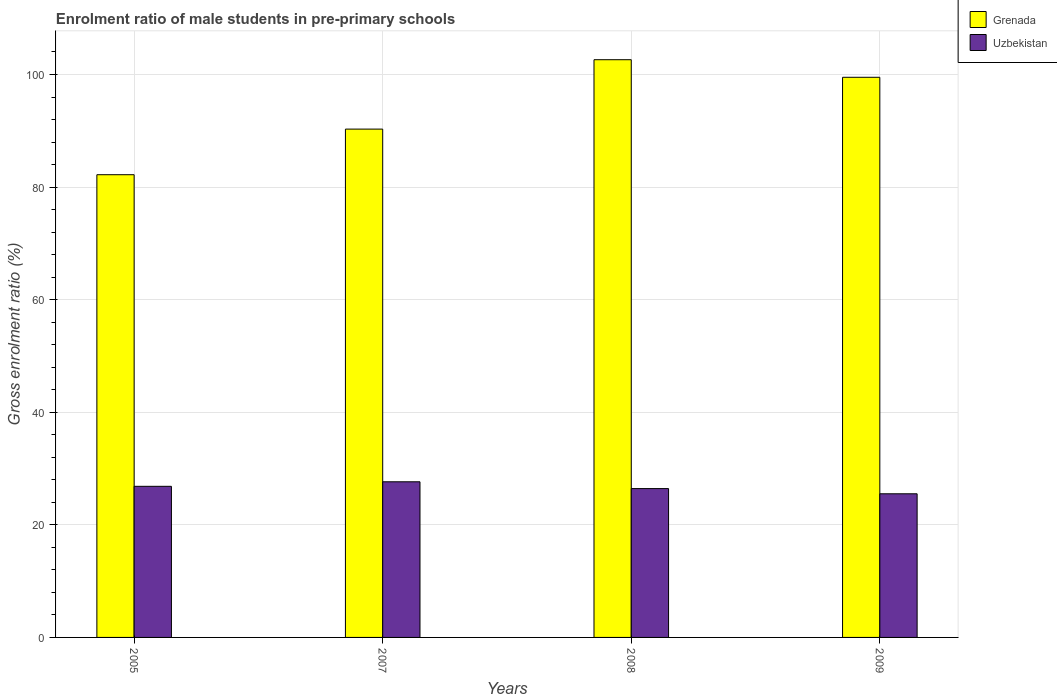How many different coloured bars are there?
Your answer should be very brief. 2. Are the number of bars on each tick of the X-axis equal?
Your response must be concise. Yes. In how many cases, is the number of bars for a given year not equal to the number of legend labels?
Offer a terse response. 0. What is the enrolment ratio of male students in pre-primary schools in Uzbekistan in 2009?
Keep it short and to the point. 25.52. Across all years, what is the maximum enrolment ratio of male students in pre-primary schools in Grenada?
Ensure brevity in your answer.  102.63. Across all years, what is the minimum enrolment ratio of male students in pre-primary schools in Grenada?
Give a very brief answer. 82.2. What is the total enrolment ratio of male students in pre-primary schools in Uzbekistan in the graph?
Your response must be concise. 106.45. What is the difference between the enrolment ratio of male students in pre-primary schools in Grenada in 2005 and that in 2007?
Your answer should be very brief. -8.1. What is the difference between the enrolment ratio of male students in pre-primary schools in Uzbekistan in 2008 and the enrolment ratio of male students in pre-primary schools in Grenada in 2009?
Offer a very short reply. -73.07. What is the average enrolment ratio of male students in pre-primary schools in Grenada per year?
Offer a terse response. 93.66. In the year 2009, what is the difference between the enrolment ratio of male students in pre-primary schools in Grenada and enrolment ratio of male students in pre-primary schools in Uzbekistan?
Provide a succinct answer. 73.99. What is the ratio of the enrolment ratio of male students in pre-primary schools in Grenada in 2005 to that in 2009?
Provide a short and direct response. 0.83. Is the enrolment ratio of male students in pre-primary schools in Grenada in 2005 less than that in 2009?
Ensure brevity in your answer.  Yes. What is the difference between the highest and the second highest enrolment ratio of male students in pre-primary schools in Grenada?
Provide a short and direct response. 3.12. What is the difference between the highest and the lowest enrolment ratio of male students in pre-primary schools in Uzbekistan?
Offer a terse response. 2.13. What does the 1st bar from the left in 2007 represents?
Your response must be concise. Grenada. What does the 2nd bar from the right in 2008 represents?
Provide a short and direct response. Grenada. How many years are there in the graph?
Make the answer very short. 4. What is the difference between two consecutive major ticks on the Y-axis?
Give a very brief answer. 20. Are the values on the major ticks of Y-axis written in scientific E-notation?
Your response must be concise. No. Does the graph contain any zero values?
Your answer should be compact. No. Where does the legend appear in the graph?
Provide a short and direct response. Top right. How many legend labels are there?
Your answer should be compact. 2. What is the title of the graph?
Provide a succinct answer. Enrolment ratio of male students in pre-primary schools. What is the label or title of the Y-axis?
Your answer should be very brief. Gross enrolment ratio (%). What is the Gross enrolment ratio (%) of Grenada in 2005?
Offer a very short reply. 82.2. What is the Gross enrolment ratio (%) in Uzbekistan in 2005?
Your answer should be very brief. 26.84. What is the Gross enrolment ratio (%) in Grenada in 2007?
Your answer should be compact. 90.3. What is the Gross enrolment ratio (%) in Uzbekistan in 2007?
Give a very brief answer. 27.65. What is the Gross enrolment ratio (%) of Grenada in 2008?
Ensure brevity in your answer.  102.63. What is the Gross enrolment ratio (%) of Uzbekistan in 2008?
Offer a very short reply. 26.44. What is the Gross enrolment ratio (%) in Grenada in 2009?
Provide a short and direct response. 99.51. What is the Gross enrolment ratio (%) in Uzbekistan in 2009?
Provide a succinct answer. 25.52. Across all years, what is the maximum Gross enrolment ratio (%) of Grenada?
Offer a very short reply. 102.63. Across all years, what is the maximum Gross enrolment ratio (%) of Uzbekistan?
Keep it short and to the point. 27.65. Across all years, what is the minimum Gross enrolment ratio (%) in Grenada?
Your response must be concise. 82.2. Across all years, what is the minimum Gross enrolment ratio (%) in Uzbekistan?
Offer a very short reply. 25.52. What is the total Gross enrolment ratio (%) of Grenada in the graph?
Your answer should be very brief. 374.64. What is the total Gross enrolment ratio (%) in Uzbekistan in the graph?
Provide a short and direct response. 106.45. What is the difference between the Gross enrolment ratio (%) of Grenada in 2005 and that in 2007?
Give a very brief answer. -8.1. What is the difference between the Gross enrolment ratio (%) in Uzbekistan in 2005 and that in 2007?
Provide a succinct answer. -0.8. What is the difference between the Gross enrolment ratio (%) in Grenada in 2005 and that in 2008?
Make the answer very short. -20.43. What is the difference between the Gross enrolment ratio (%) in Uzbekistan in 2005 and that in 2008?
Offer a very short reply. 0.4. What is the difference between the Gross enrolment ratio (%) of Grenada in 2005 and that in 2009?
Keep it short and to the point. -17.31. What is the difference between the Gross enrolment ratio (%) of Uzbekistan in 2005 and that in 2009?
Give a very brief answer. 1.33. What is the difference between the Gross enrolment ratio (%) in Grenada in 2007 and that in 2008?
Keep it short and to the point. -12.33. What is the difference between the Gross enrolment ratio (%) of Uzbekistan in 2007 and that in 2008?
Offer a very short reply. 1.21. What is the difference between the Gross enrolment ratio (%) in Grenada in 2007 and that in 2009?
Ensure brevity in your answer.  -9.2. What is the difference between the Gross enrolment ratio (%) of Uzbekistan in 2007 and that in 2009?
Offer a very short reply. 2.13. What is the difference between the Gross enrolment ratio (%) in Grenada in 2008 and that in 2009?
Your answer should be compact. 3.12. What is the difference between the Gross enrolment ratio (%) of Uzbekistan in 2008 and that in 2009?
Keep it short and to the point. 0.92. What is the difference between the Gross enrolment ratio (%) in Grenada in 2005 and the Gross enrolment ratio (%) in Uzbekistan in 2007?
Provide a succinct answer. 54.55. What is the difference between the Gross enrolment ratio (%) of Grenada in 2005 and the Gross enrolment ratio (%) of Uzbekistan in 2008?
Offer a very short reply. 55.76. What is the difference between the Gross enrolment ratio (%) in Grenada in 2005 and the Gross enrolment ratio (%) in Uzbekistan in 2009?
Provide a short and direct response. 56.68. What is the difference between the Gross enrolment ratio (%) in Grenada in 2007 and the Gross enrolment ratio (%) in Uzbekistan in 2008?
Your answer should be compact. 63.86. What is the difference between the Gross enrolment ratio (%) in Grenada in 2007 and the Gross enrolment ratio (%) in Uzbekistan in 2009?
Your answer should be compact. 64.79. What is the difference between the Gross enrolment ratio (%) of Grenada in 2008 and the Gross enrolment ratio (%) of Uzbekistan in 2009?
Make the answer very short. 77.11. What is the average Gross enrolment ratio (%) in Grenada per year?
Provide a succinct answer. 93.66. What is the average Gross enrolment ratio (%) in Uzbekistan per year?
Your answer should be compact. 26.61. In the year 2005, what is the difference between the Gross enrolment ratio (%) of Grenada and Gross enrolment ratio (%) of Uzbekistan?
Ensure brevity in your answer.  55.35. In the year 2007, what is the difference between the Gross enrolment ratio (%) in Grenada and Gross enrolment ratio (%) in Uzbekistan?
Provide a succinct answer. 62.65. In the year 2008, what is the difference between the Gross enrolment ratio (%) of Grenada and Gross enrolment ratio (%) of Uzbekistan?
Provide a succinct answer. 76.19. In the year 2009, what is the difference between the Gross enrolment ratio (%) of Grenada and Gross enrolment ratio (%) of Uzbekistan?
Offer a terse response. 73.99. What is the ratio of the Gross enrolment ratio (%) of Grenada in 2005 to that in 2007?
Give a very brief answer. 0.91. What is the ratio of the Gross enrolment ratio (%) of Uzbekistan in 2005 to that in 2007?
Your answer should be compact. 0.97. What is the ratio of the Gross enrolment ratio (%) in Grenada in 2005 to that in 2008?
Provide a short and direct response. 0.8. What is the ratio of the Gross enrolment ratio (%) in Uzbekistan in 2005 to that in 2008?
Provide a short and direct response. 1.02. What is the ratio of the Gross enrolment ratio (%) in Grenada in 2005 to that in 2009?
Make the answer very short. 0.83. What is the ratio of the Gross enrolment ratio (%) of Uzbekistan in 2005 to that in 2009?
Offer a terse response. 1.05. What is the ratio of the Gross enrolment ratio (%) in Grenada in 2007 to that in 2008?
Your response must be concise. 0.88. What is the ratio of the Gross enrolment ratio (%) of Uzbekistan in 2007 to that in 2008?
Ensure brevity in your answer.  1.05. What is the ratio of the Gross enrolment ratio (%) in Grenada in 2007 to that in 2009?
Your answer should be very brief. 0.91. What is the ratio of the Gross enrolment ratio (%) of Uzbekistan in 2007 to that in 2009?
Give a very brief answer. 1.08. What is the ratio of the Gross enrolment ratio (%) of Grenada in 2008 to that in 2009?
Ensure brevity in your answer.  1.03. What is the ratio of the Gross enrolment ratio (%) of Uzbekistan in 2008 to that in 2009?
Give a very brief answer. 1.04. What is the difference between the highest and the second highest Gross enrolment ratio (%) in Grenada?
Your answer should be very brief. 3.12. What is the difference between the highest and the second highest Gross enrolment ratio (%) in Uzbekistan?
Make the answer very short. 0.8. What is the difference between the highest and the lowest Gross enrolment ratio (%) in Grenada?
Your answer should be very brief. 20.43. What is the difference between the highest and the lowest Gross enrolment ratio (%) in Uzbekistan?
Offer a terse response. 2.13. 